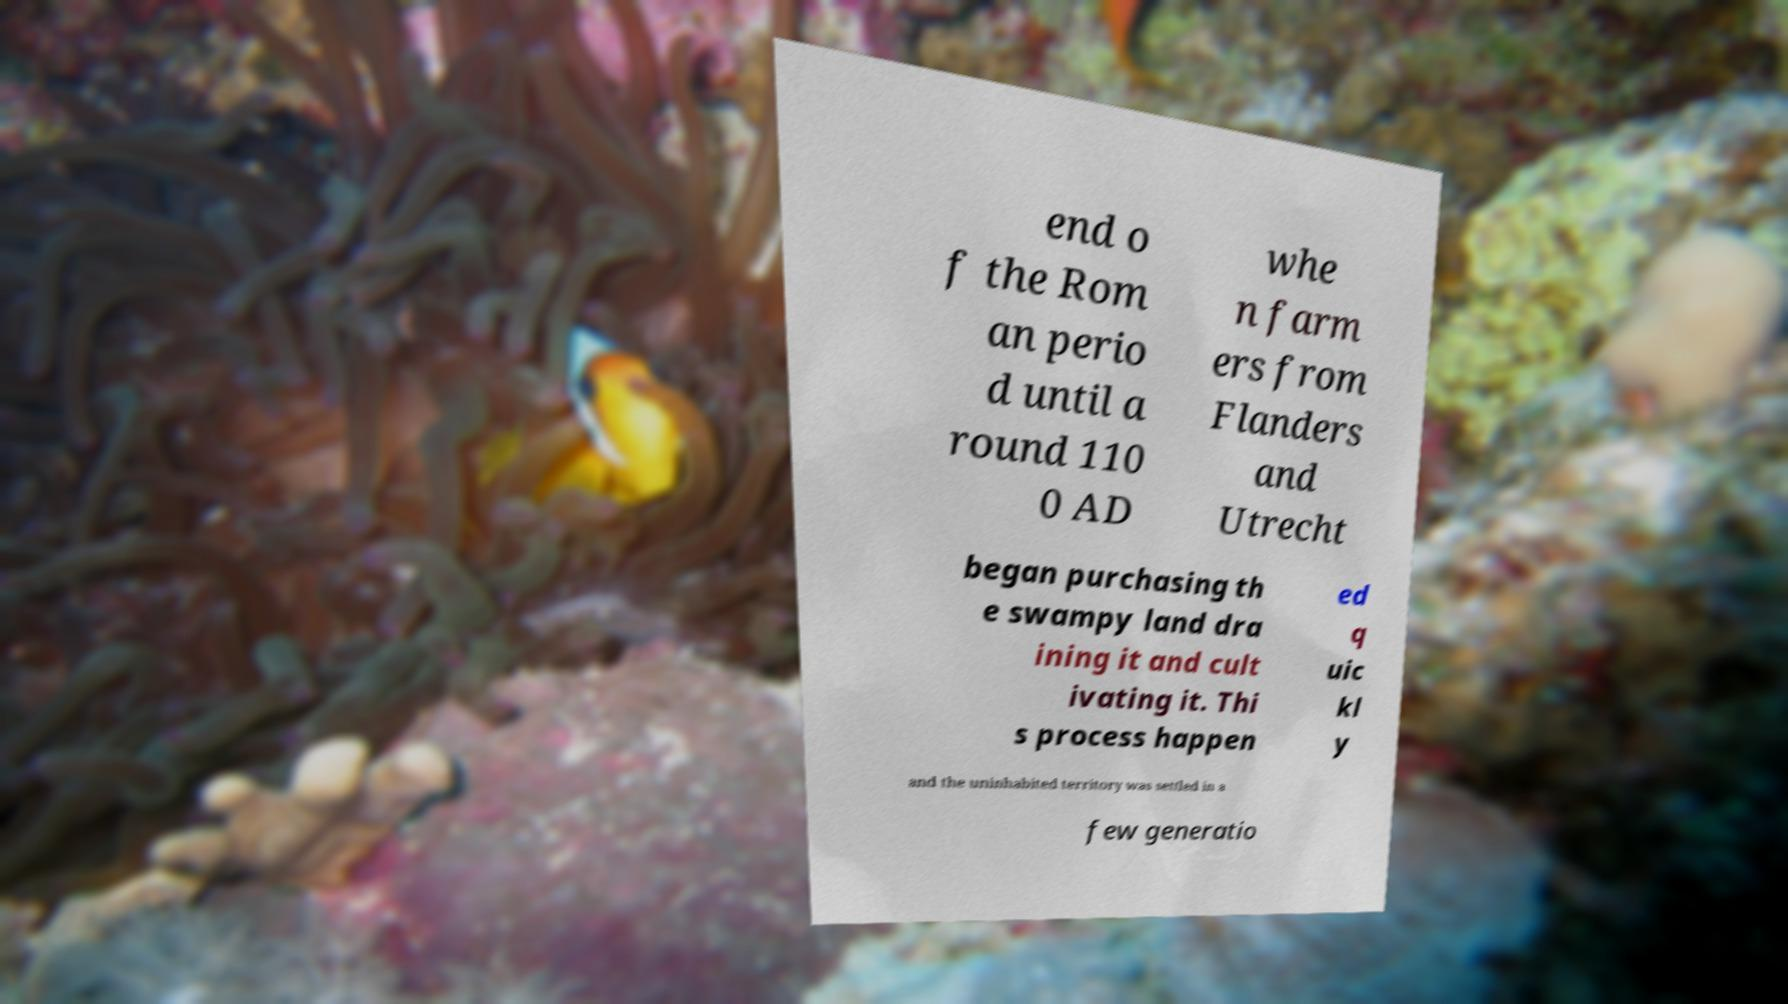There's text embedded in this image that I need extracted. Can you transcribe it verbatim? end o f the Rom an perio d until a round 110 0 AD whe n farm ers from Flanders and Utrecht began purchasing th e swampy land dra ining it and cult ivating it. Thi s process happen ed q uic kl y and the uninhabited territory was settled in a few generatio 